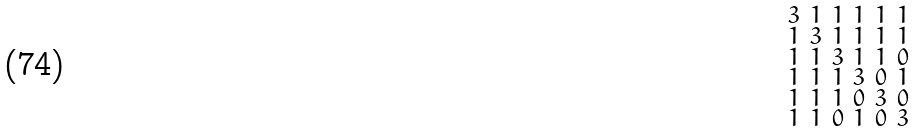Convert formula to latex. <formula><loc_0><loc_0><loc_500><loc_500>\begin{smallmatrix} 3 & 1 & 1 & 1 & 1 & 1 \\ 1 & 3 & 1 & 1 & 1 & 1 \\ 1 & 1 & 3 & 1 & 1 & 0 \\ 1 & 1 & 1 & 3 & 0 & 1 \\ 1 & 1 & 1 & 0 & 3 & 0 \\ 1 & 1 & 0 & 1 & 0 & 3 \end{smallmatrix}</formula> 